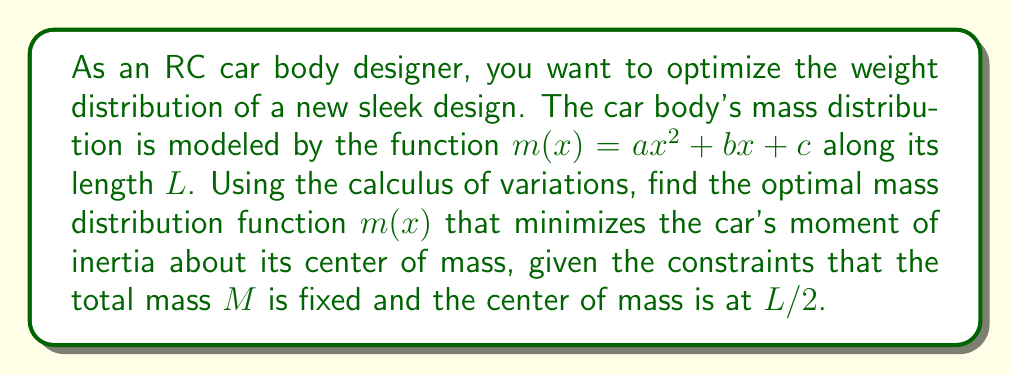Provide a solution to this math problem. Let's approach this step-by-step:

1) The moment of inertia $I$ about the center of mass is given by:

   $$I = \int_0^L (x - \frac{L}{2})^2 m(x) dx$$

2) We have two constraints:
   a) Total mass: $\int_0^L m(x) dx = M$
   b) Center of mass at $L/2$: $\int_0^L x m(x) dx = \frac{ML}{2}$

3) We need to minimize $I$ subject to these constraints. We can use the method of Lagrange multipliers. Let's form the functional:

   $$J[m] = \int_0^L [(x - \frac{L}{2})^2 m(x) + \lambda_1 m(x) + \lambda_2 x m(x)] dx - \lambda_1 M - \lambda_2 \frac{ML}{2}$$

4) The Euler-Lagrange equation for this problem is:

   $$\frac{\partial}{\partial m} [(x - \frac{L}{2})^2 m + \lambda_1 m + \lambda_2 x m] = 0$$

5) Simplifying:

   $$(x - \frac{L}{2})^2 + \lambda_1 + \lambda_2 x = 0$$

6) This equation should hold for all $x$, which means:

   $$x^2 - Lx + \frac{L^2}{4} + \lambda_1 + \lambda_2 x = 0$$

7) Comparing coefficients:

   $$a = 1, \quad b = -L + \lambda_2, \quad c = \frac{L^2}{4} + \lambda_1$$

8) We can determine $\lambda_1$ and $\lambda_2$ using the constraints, but the key result is that the optimal mass distribution is indeed a quadratic function:

   $$m(x) = ax^2 + bx + c$$

9) This quadratic distribution concentrates more mass near the ends of the car body, reducing the moment of inertia while maintaining the center of mass at the midpoint.
Answer: $m(x) = ax^2 + bx + c$, where $a > 0$ 